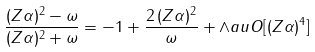<formula> <loc_0><loc_0><loc_500><loc_500>\frac { ( Z \alpha ) ^ { 2 } - \omega } { ( Z \alpha ) ^ { 2 } + \omega } = - 1 + \frac { 2 \, ( Z \alpha ) ^ { 2 } } { \omega } + \land a u O [ ( Z \alpha ) ^ { 4 } ]</formula> 